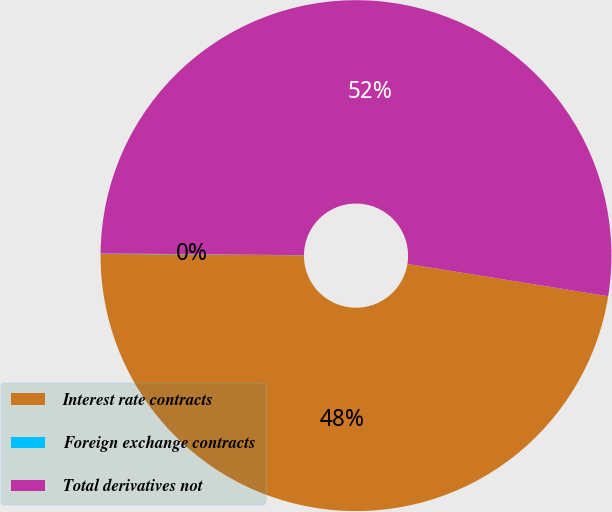Convert chart. <chart><loc_0><loc_0><loc_500><loc_500><pie_chart><fcel>Interest rate contracts<fcel>Foreign exchange contracts<fcel>Total derivatives not<nl><fcel>47.57%<fcel>0.03%<fcel>52.41%<nl></chart> 